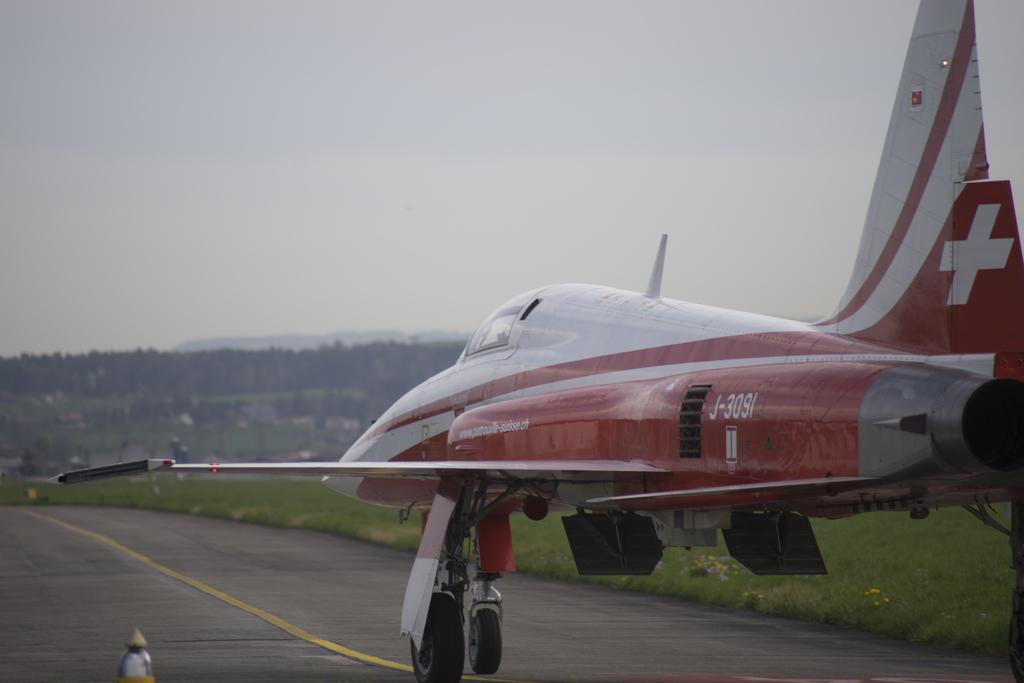What is the main subject of the image? The main subject of the image is an airplane on the ground. What type of natural environment is visible in the image? There are trees and grass visible in the image. What can be seen in the background of the image? The sky is visible in the background of the image. What color is the crayon being used to draw on the airplane in the image? There is no crayon or drawing present on the airplane in the image. 